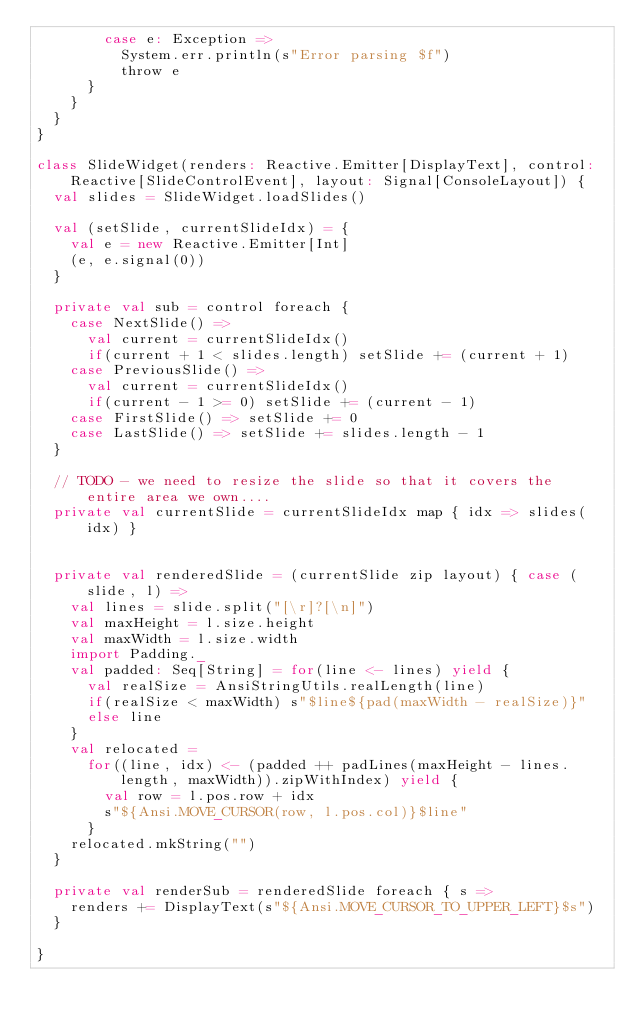<code> <loc_0><loc_0><loc_500><loc_500><_Scala_>        case e: Exception =>
          System.err.println(s"Error parsing $f")
          throw e
      }
    }
  }
}

class SlideWidget(renders: Reactive.Emitter[DisplayText], control: Reactive[SlideControlEvent], layout: Signal[ConsoleLayout]) {
  val slides = SlideWidget.loadSlides()

  val (setSlide, currentSlideIdx) = {
    val e = new Reactive.Emitter[Int]
    (e, e.signal(0))
  }

  private val sub = control foreach {
    case NextSlide() =>
      val current = currentSlideIdx()
      if(current + 1 < slides.length) setSlide += (current + 1)
    case PreviousSlide() =>
      val current = currentSlideIdx()
      if(current - 1 >= 0) setSlide += (current - 1)
    case FirstSlide() => setSlide += 0
    case LastSlide() => setSlide += slides.length - 1
  }

  // TODO - we need to resize the slide so that it covers the entire area we own....
  private val currentSlide = currentSlideIdx map { idx => slides(idx) }


  private val renderedSlide = (currentSlide zip layout) { case (slide, l) =>
    val lines = slide.split("[\r]?[\n]")
    val maxHeight = l.size.height
    val maxWidth = l.size.width
    import Padding._
    val padded: Seq[String] = for(line <- lines) yield {
      val realSize = AnsiStringUtils.realLength(line)
      if(realSize < maxWidth) s"$line${pad(maxWidth - realSize)}"
      else line
    }
    val relocated =
      for((line, idx) <- (padded ++ padLines(maxHeight - lines.length, maxWidth)).zipWithIndex) yield {
        val row = l.pos.row + idx
        s"${Ansi.MOVE_CURSOR(row, l.pos.col)}$line"
      }
    relocated.mkString("")
  }

  private val renderSub = renderedSlide foreach { s =>
    renders += DisplayText(s"${Ansi.MOVE_CURSOR_TO_UPPER_LEFT}$s")
  }

}
</code> 